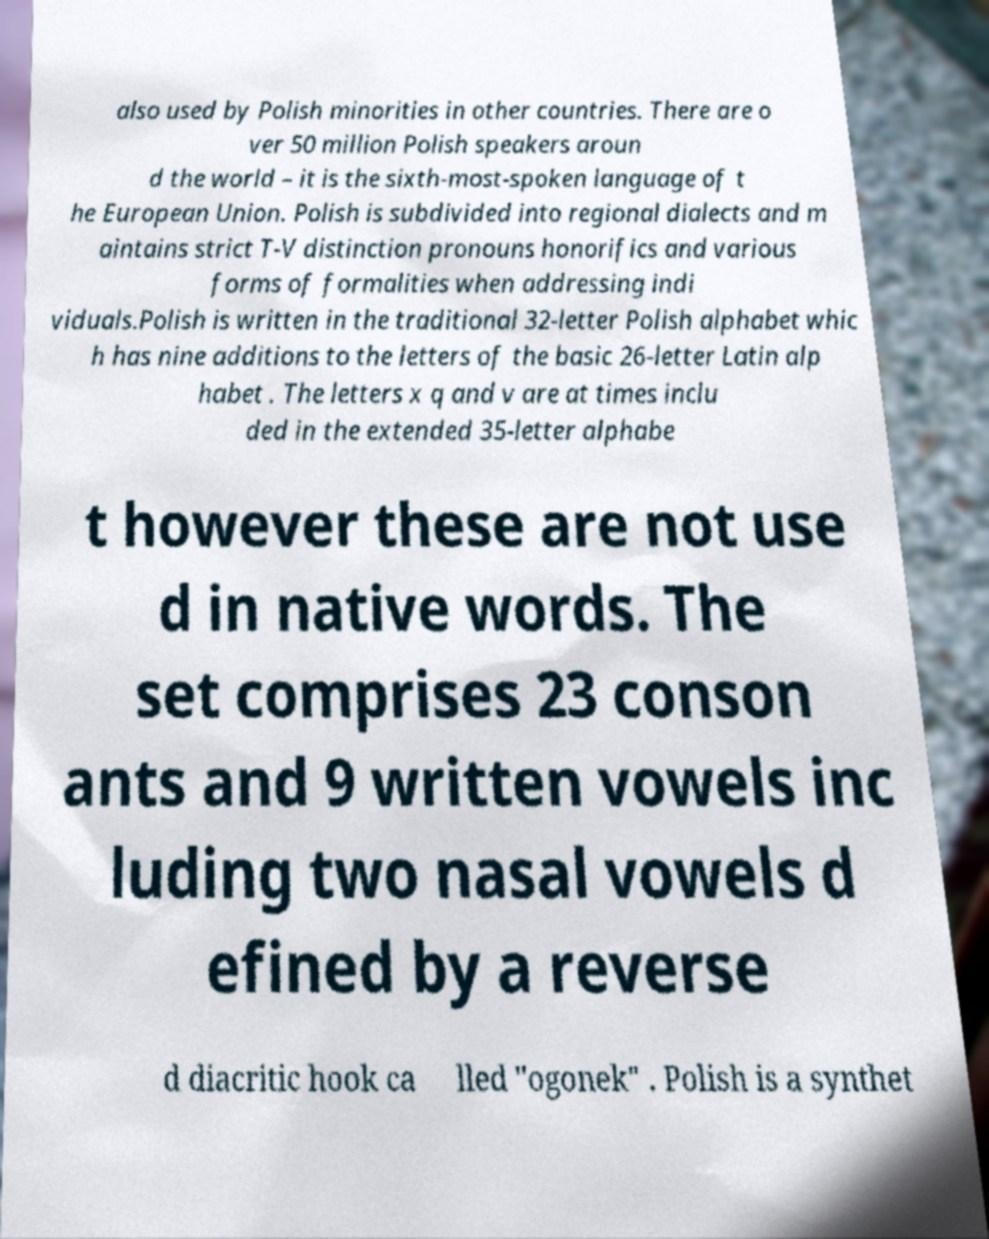Could you assist in decoding the text presented in this image and type it out clearly? also used by Polish minorities in other countries. There are o ver 50 million Polish speakers aroun d the world – it is the sixth-most-spoken language of t he European Union. Polish is subdivided into regional dialects and m aintains strict T-V distinction pronouns honorifics and various forms of formalities when addressing indi viduals.Polish is written in the traditional 32-letter Polish alphabet whic h has nine additions to the letters of the basic 26-letter Latin alp habet . The letters x q and v are at times inclu ded in the extended 35-letter alphabe t however these are not use d in native words. The set comprises 23 conson ants and 9 written vowels inc luding two nasal vowels d efined by a reverse d diacritic hook ca lled "ogonek" . Polish is a synthet 